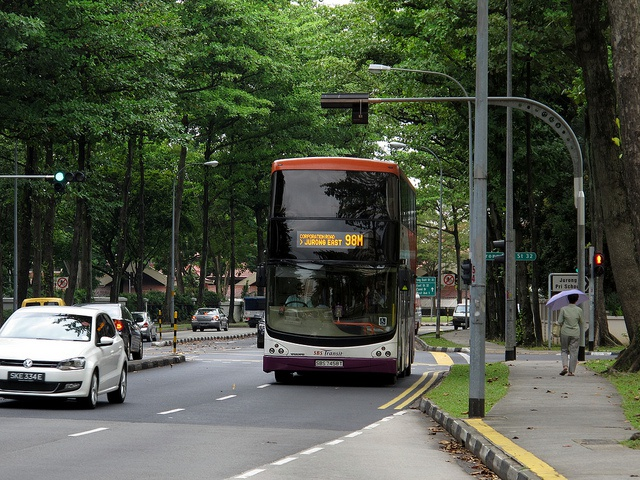Describe the objects in this image and their specific colors. I can see bus in black, gray, darkgray, and darkgreen tones, car in black, white, darkgray, and gray tones, people in black and gray tones, car in black, gray, lightgray, and darkgray tones, and traffic light in black, gray, and darkgreen tones in this image. 